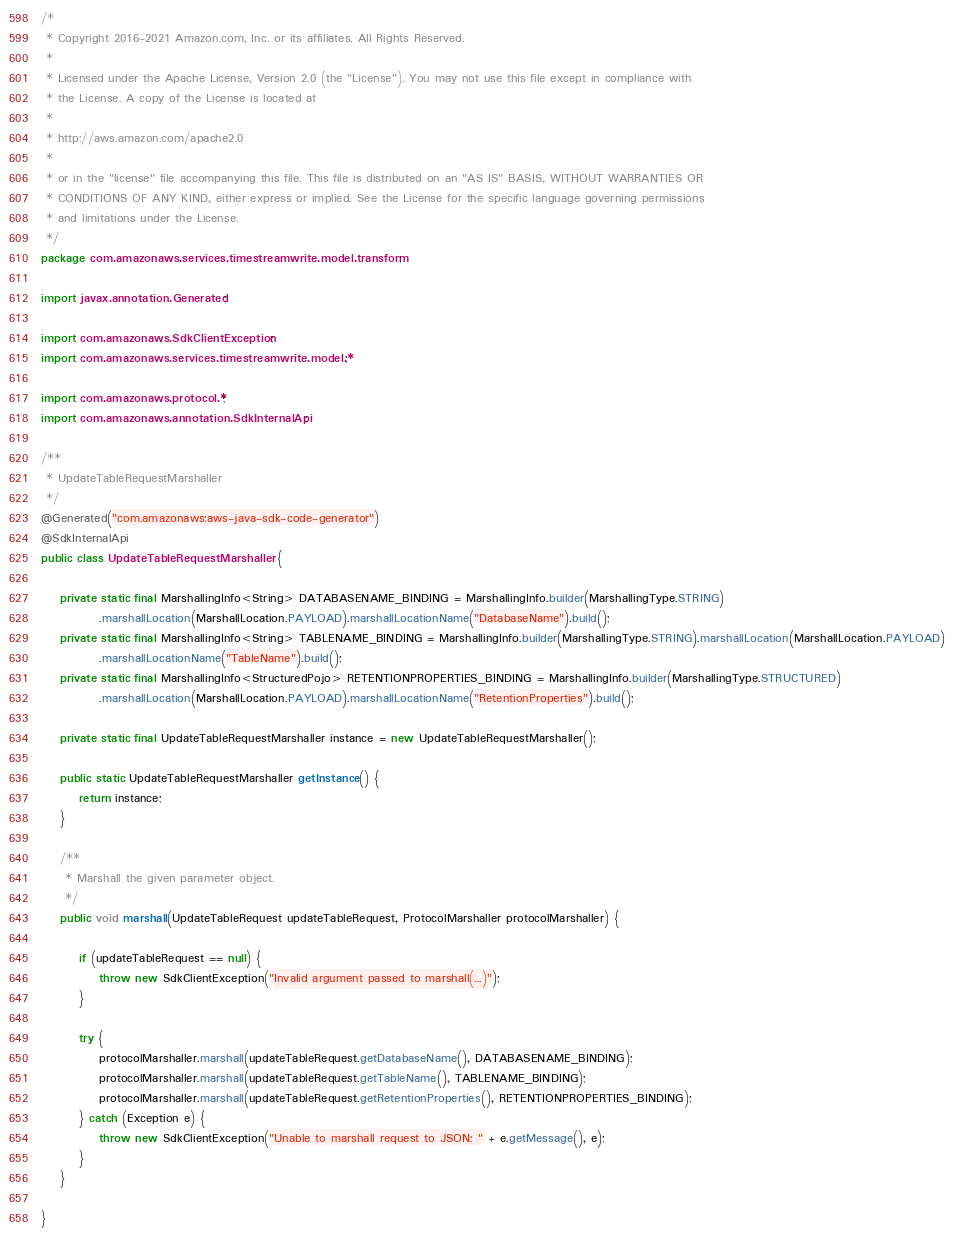Convert code to text. <code><loc_0><loc_0><loc_500><loc_500><_Java_>/*
 * Copyright 2016-2021 Amazon.com, Inc. or its affiliates. All Rights Reserved.
 * 
 * Licensed under the Apache License, Version 2.0 (the "License"). You may not use this file except in compliance with
 * the License. A copy of the License is located at
 * 
 * http://aws.amazon.com/apache2.0
 * 
 * or in the "license" file accompanying this file. This file is distributed on an "AS IS" BASIS, WITHOUT WARRANTIES OR
 * CONDITIONS OF ANY KIND, either express or implied. See the License for the specific language governing permissions
 * and limitations under the License.
 */
package com.amazonaws.services.timestreamwrite.model.transform;

import javax.annotation.Generated;

import com.amazonaws.SdkClientException;
import com.amazonaws.services.timestreamwrite.model.*;

import com.amazonaws.protocol.*;
import com.amazonaws.annotation.SdkInternalApi;

/**
 * UpdateTableRequestMarshaller
 */
@Generated("com.amazonaws:aws-java-sdk-code-generator")
@SdkInternalApi
public class UpdateTableRequestMarshaller {

    private static final MarshallingInfo<String> DATABASENAME_BINDING = MarshallingInfo.builder(MarshallingType.STRING)
            .marshallLocation(MarshallLocation.PAYLOAD).marshallLocationName("DatabaseName").build();
    private static final MarshallingInfo<String> TABLENAME_BINDING = MarshallingInfo.builder(MarshallingType.STRING).marshallLocation(MarshallLocation.PAYLOAD)
            .marshallLocationName("TableName").build();
    private static final MarshallingInfo<StructuredPojo> RETENTIONPROPERTIES_BINDING = MarshallingInfo.builder(MarshallingType.STRUCTURED)
            .marshallLocation(MarshallLocation.PAYLOAD).marshallLocationName("RetentionProperties").build();

    private static final UpdateTableRequestMarshaller instance = new UpdateTableRequestMarshaller();

    public static UpdateTableRequestMarshaller getInstance() {
        return instance;
    }

    /**
     * Marshall the given parameter object.
     */
    public void marshall(UpdateTableRequest updateTableRequest, ProtocolMarshaller protocolMarshaller) {

        if (updateTableRequest == null) {
            throw new SdkClientException("Invalid argument passed to marshall(...)");
        }

        try {
            protocolMarshaller.marshall(updateTableRequest.getDatabaseName(), DATABASENAME_BINDING);
            protocolMarshaller.marshall(updateTableRequest.getTableName(), TABLENAME_BINDING);
            protocolMarshaller.marshall(updateTableRequest.getRetentionProperties(), RETENTIONPROPERTIES_BINDING);
        } catch (Exception e) {
            throw new SdkClientException("Unable to marshall request to JSON: " + e.getMessage(), e);
        }
    }

}
</code> 